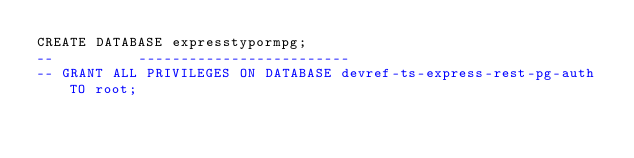<code> <loc_0><loc_0><loc_500><loc_500><_SQL_>CREATE DATABASE expresstypormpg;
--          -------------------------
-- GRANT ALL PRIVILEGES ON DATABASE devref-ts-express-rest-pg-auth TO root;</code> 